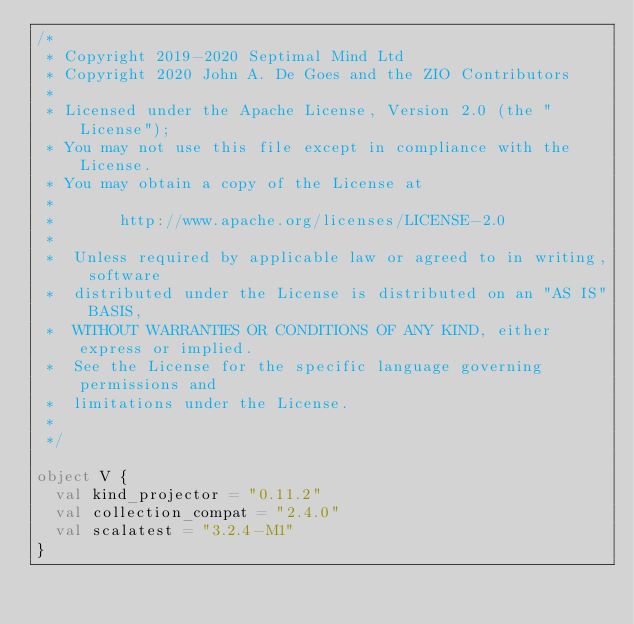Convert code to text. <code><loc_0><loc_0><loc_500><loc_500><_Scala_>/*
 * Copyright 2019-2020 Septimal Mind Ltd
 * Copyright 2020 John A. De Goes and the ZIO Contributors
 *
 * Licensed under the Apache License, Version 2.0 (the "License");
 * You may not use this file except in compliance with the License.
 * You may obtain a copy of the License at
 *
 *       http://www.apache.org/licenses/LICENSE-2.0
 *
 *  Unless required by applicable law or agreed to in writing, software
 *  distributed under the License is distributed on an "AS IS" BASIS,
 *  WITHOUT WARRANTIES OR CONDITIONS OF ANY KIND, either express or implied.
 *  See the License for the specific language governing permissions and
 *  limitations under the License.
 *
 */

object V {
  val kind_projector = "0.11.2"
  val collection_compat = "2.4.0"
  val scalatest = "3.2.4-M1"
}
</code> 